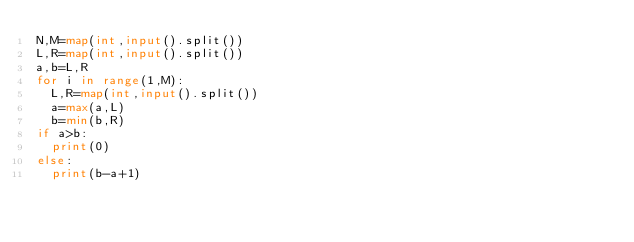<code> <loc_0><loc_0><loc_500><loc_500><_Python_>N,M=map(int,input().split())
L,R=map(int,input().split())
a,b=L,R
for i in range(1,M):
  L,R=map(int,input().split())
  a=max(a,L)
  b=min(b,R)
if a>b:
  print(0)
else:
  print(b-a+1)</code> 